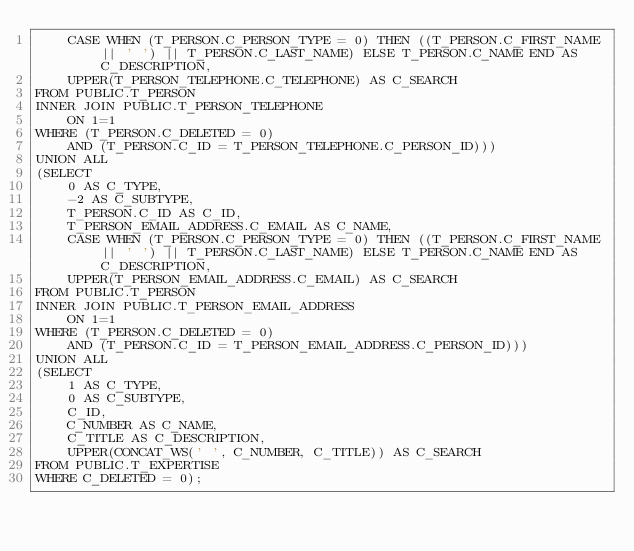<code> <loc_0><loc_0><loc_500><loc_500><_SQL_>    CASE WHEN (T_PERSON.C_PERSON_TYPE = 0) THEN ((T_PERSON.C_FIRST_NAME || ' ') || T_PERSON.C_LAST_NAME) ELSE T_PERSON.C_NAME END AS C_DESCRIPTION,
    UPPER(T_PERSON_TELEPHONE.C_TELEPHONE) AS C_SEARCH
FROM PUBLIC.T_PERSON
INNER JOIN PUBLIC.T_PERSON_TELEPHONE
    ON 1=1
WHERE (T_PERSON.C_DELETED = 0)
    AND (T_PERSON.C_ID = T_PERSON_TELEPHONE.C_PERSON_ID)))
UNION ALL
(SELECT
    0 AS C_TYPE,
    -2 AS C_SUBTYPE,
    T_PERSON.C_ID AS C_ID,
    T_PERSON_EMAIL_ADDRESS.C_EMAIL AS C_NAME,
    CASE WHEN (T_PERSON.C_PERSON_TYPE = 0) THEN ((T_PERSON.C_FIRST_NAME || ' ') || T_PERSON.C_LAST_NAME) ELSE T_PERSON.C_NAME END AS C_DESCRIPTION,
    UPPER(T_PERSON_EMAIL_ADDRESS.C_EMAIL) AS C_SEARCH
FROM PUBLIC.T_PERSON
INNER JOIN PUBLIC.T_PERSON_EMAIL_ADDRESS
    ON 1=1
WHERE (T_PERSON.C_DELETED = 0)
    AND (T_PERSON.C_ID = T_PERSON_EMAIL_ADDRESS.C_PERSON_ID)))
UNION ALL
(SELECT
    1 AS C_TYPE,
    0 AS C_SUBTYPE,
    C_ID,
    C_NUMBER AS C_NAME,
    C_TITLE AS C_DESCRIPTION,
    UPPER(CONCAT_WS(' ', C_NUMBER, C_TITLE)) AS C_SEARCH
FROM PUBLIC.T_EXPERTISE
WHERE C_DELETED = 0);
</code> 